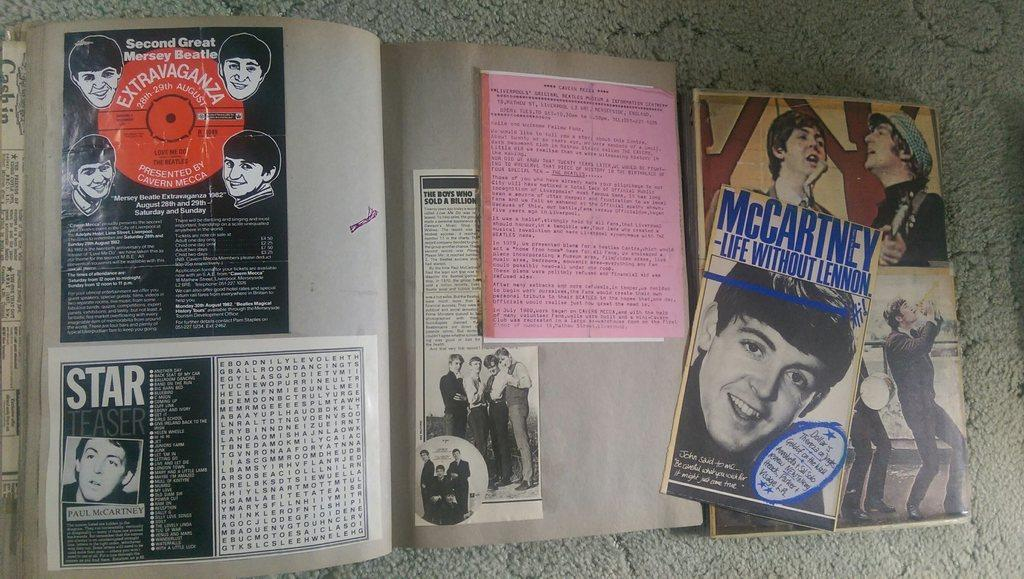Provide a one-sentence caption for the provided image. A billboard displays photos and written descriptions of Paul McCartney. 